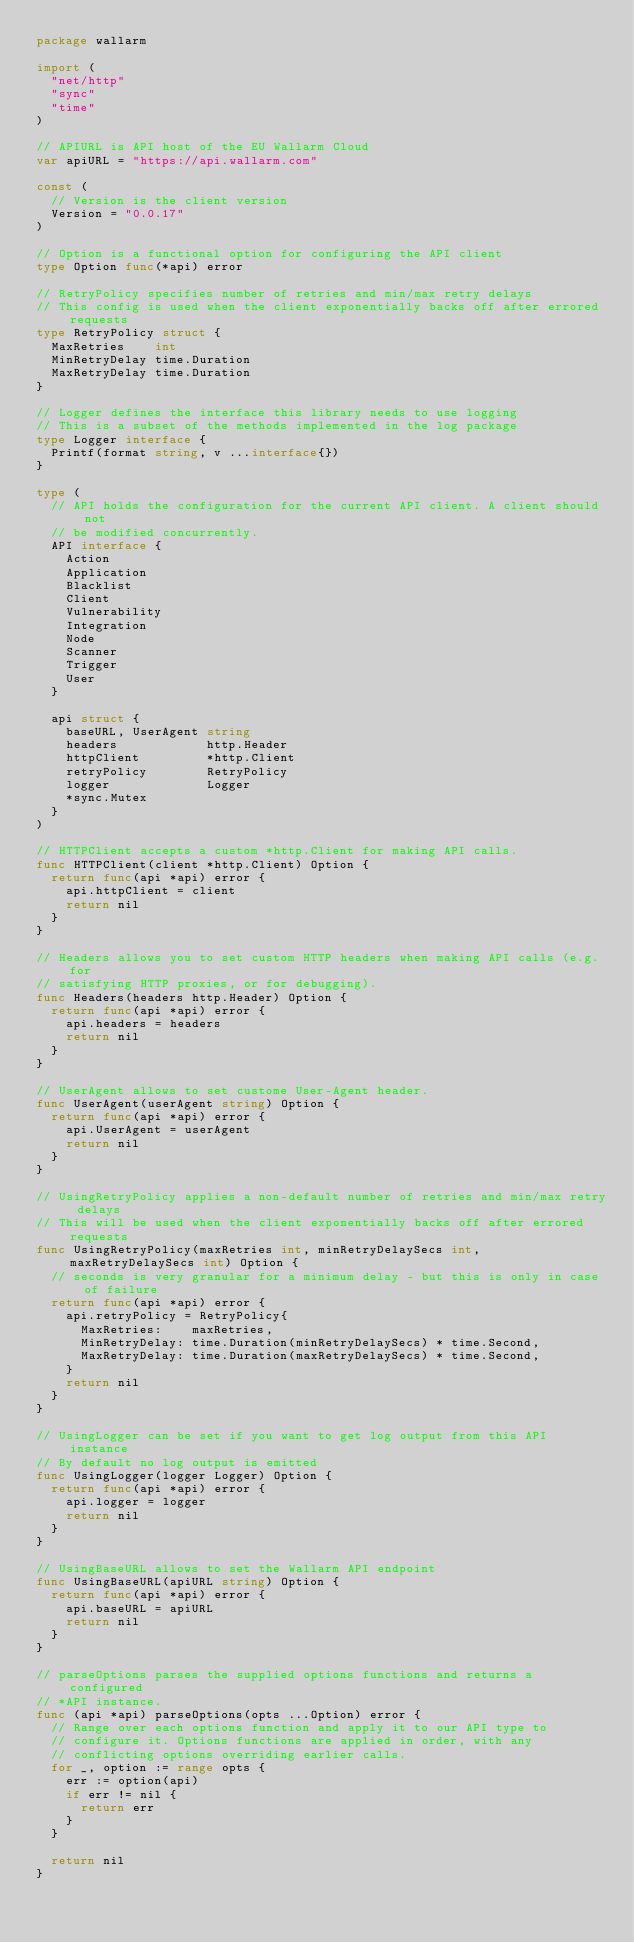Convert code to text. <code><loc_0><loc_0><loc_500><loc_500><_Go_>package wallarm

import (
	"net/http"
	"sync"
	"time"
)

// APIURL is API host of the EU Wallarm Cloud
var apiURL = "https://api.wallarm.com"

const (
	// Version is the client version
	Version = "0.0.17"
)

// Option is a functional option for configuring the API client
type Option func(*api) error

// RetryPolicy specifies number of retries and min/max retry delays
// This config is used when the client exponentially backs off after errored requests
type RetryPolicy struct {
	MaxRetries    int
	MinRetryDelay time.Duration
	MaxRetryDelay time.Duration
}

// Logger defines the interface this library needs to use logging
// This is a subset of the methods implemented in the log package
type Logger interface {
	Printf(format string, v ...interface{})
}

type (
	// API holds the configuration for the current API client. A client should not
	// be modified concurrently.
	API interface {
		Action
		Application
		Blacklist
		Client
		Vulnerability
		Integration
		Node
		Scanner
		Trigger
		User
	}

	api struct {
		baseURL, UserAgent string
		headers            http.Header
		httpClient         *http.Client
		retryPolicy        RetryPolicy
		logger             Logger
		*sync.Mutex
	}
)

// HTTPClient accepts a custom *http.Client for making API calls.
func HTTPClient(client *http.Client) Option {
	return func(api *api) error {
		api.httpClient = client
		return nil
	}
}

// Headers allows you to set custom HTTP headers when making API calls (e.g. for
// satisfying HTTP proxies, or for debugging).
func Headers(headers http.Header) Option {
	return func(api *api) error {
		api.headers = headers
		return nil
	}
}

// UserAgent allows to set custome User-Agent header.
func UserAgent(userAgent string) Option {
	return func(api *api) error {
		api.UserAgent = userAgent
		return nil
	}
}

// UsingRetryPolicy applies a non-default number of retries and min/max retry delays
// This will be used when the client exponentially backs off after errored requests
func UsingRetryPolicy(maxRetries int, minRetryDelaySecs int, maxRetryDelaySecs int) Option {
	// seconds is very granular for a minimum delay - but this is only in case of failure
	return func(api *api) error {
		api.retryPolicy = RetryPolicy{
			MaxRetries:    maxRetries,
			MinRetryDelay: time.Duration(minRetryDelaySecs) * time.Second,
			MaxRetryDelay: time.Duration(maxRetryDelaySecs) * time.Second,
		}
		return nil
	}
}

// UsingLogger can be set if you want to get log output from this API instance
// By default no log output is emitted
func UsingLogger(logger Logger) Option {
	return func(api *api) error {
		api.logger = logger
		return nil
	}
}

// UsingBaseURL allows to set the Wallarm API endpoint
func UsingBaseURL(apiURL string) Option {
	return func(api *api) error {
		api.baseURL = apiURL
		return nil
	}
}

// parseOptions parses the supplied options functions and returns a configured
// *API instance.
func (api *api) parseOptions(opts ...Option) error {
	// Range over each options function and apply it to our API type to
	// configure it. Options functions are applied in order, with any
	// conflicting options overriding earlier calls.
	for _, option := range opts {
		err := option(api)
		if err != nil {
			return err
		}
	}

	return nil
}
</code> 